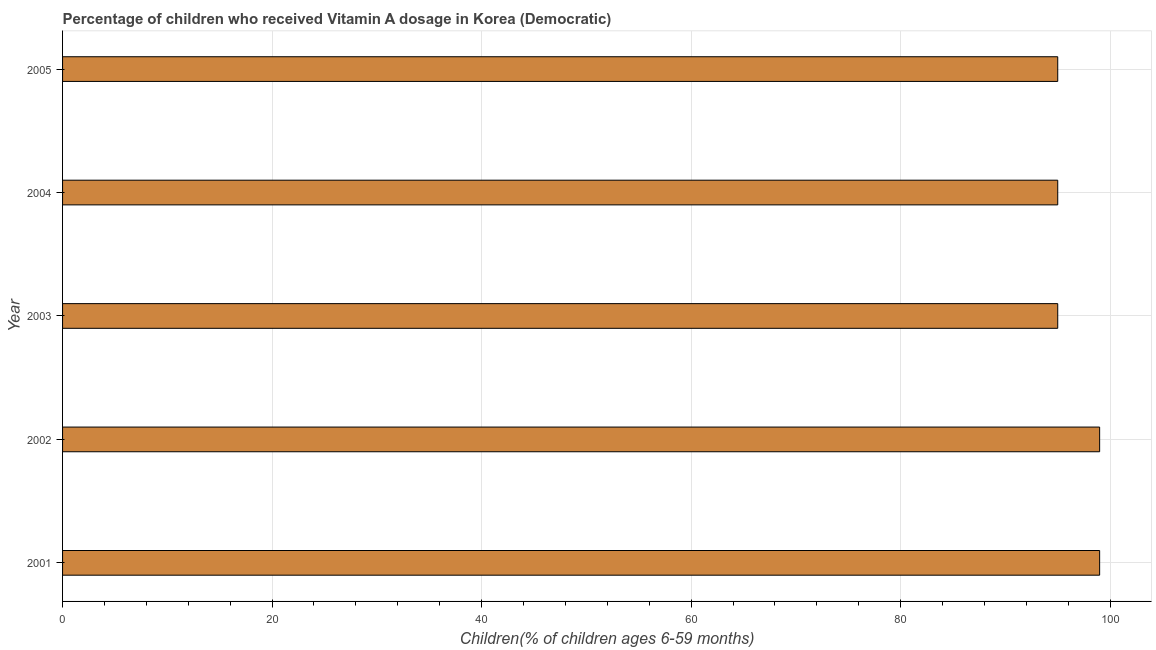Does the graph contain grids?
Your response must be concise. Yes. What is the title of the graph?
Keep it short and to the point. Percentage of children who received Vitamin A dosage in Korea (Democratic). What is the label or title of the X-axis?
Provide a short and direct response. Children(% of children ages 6-59 months). Across all years, what is the minimum vitamin a supplementation coverage rate?
Give a very brief answer. 95. In which year was the vitamin a supplementation coverage rate minimum?
Offer a very short reply. 2003. What is the sum of the vitamin a supplementation coverage rate?
Keep it short and to the point. 483. What is the average vitamin a supplementation coverage rate per year?
Make the answer very short. 96.6. What is the median vitamin a supplementation coverage rate?
Ensure brevity in your answer.  95. What is the ratio of the vitamin a supplementation coverage rate in 2002 to that in 2003?
Offer a terse response. 1.04. Is the vitamin a supplementation coverage rate in 2001 less than that in 2003?
Offer a terse response. No. Is the difference between the vitamin a supplementation coverage rate in 2003 and 2004 greater than the difference between any two years?
Provide a short and direct response. No. What is the difference between the highest and the second highest vitamin a supplementation coverage rate?
Make the answer very short. 0. Is the sum of the vitamin a supplementation coverage rate in 2003 and 2005 greater than the maximum vitamin a supplementation coverage rate across all years?
Ensure brevity in your answer.  Yes. What is the difference between the highest and the lowest vitamin a supplementation coverage rate?
Keep it short and to the point. 4. What is the Children(% of children ages 6-59 months) of 2001?
Keep it short and to the point. 99. What is the Children(% of children ages 6-59 months) of 2002?
Give a very brief answer. 99. What is the Children(% of children ages 6-59 months) in 2003?
Give a very brief answer. 95. What is the difference between the Children(% of children ages 6-59 months) in 2001 and 2002?
Give a very brief answer. 0. What is the difference between the Children(% of children ages 6-59 months) in 2001 and 2004?
Offer a very short reply. 4. What is the difference between the Children(% of children ages 6-59 months) in 2003 and 2004?
Offer a terse response. 0. What is the difference between the Children(% of children ages 6-59 months) in 2003 and 2005?
Offer a terse response. 0. What is the difference between the Children(% of children ages 6-59 months) in 2004 and 2005?
Keep it short and to the point. 0. What is the ratio of the Children(% of children ages 6-59 months) in 2001 to that in 2003?
Offer a very short reply. 1.04. What is the ratio of the Children(% of children ages 6-59 months) in 2001 to that in 2004?
Your answer should be very brief. 1.04. What is the ratio of the Children(% of children ages 6-59 months) in 2001 to that in 2005?
Keep it short and to the point. 1.04. What is the ratio of the Children(% of children ages 6-59 months) in 2002 to that in 2003?
Your answer should be very brief. 1.04. What is the ratio of the Children(% of children ages 6-59 months) in 2002 to that in 2004?
Give a very brief answer. 1.04. What is the ratio of the Children(% of children ages 6-59 months) in 2002 to that in 2005?
Ensure brevity in your answer.  1.04. What is the ratio of the Children(% of children ages 6-59 months) in 2003 to that in 2005?
Offer a terse response. 1. What is the ratio of the Children(% of children ages 6-59 months) in 2004 to that in 2005?
Your response must be concise. 1. 